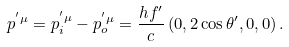Convert formula to latex. <formula><loc_0><loc_0><loc_500><loc_500>p ^ { ^ { \prime } \mu } = p _ { i } ^ { ^ { \prime } \mu } - p _ { o } ^ { ^ { \prime } \mu } = \frac { h f ^ { \prime } } { c } \left ( 0 , 2 \cos \theta ^ { \prime } , 0 , 0 \right ) .</formula> 